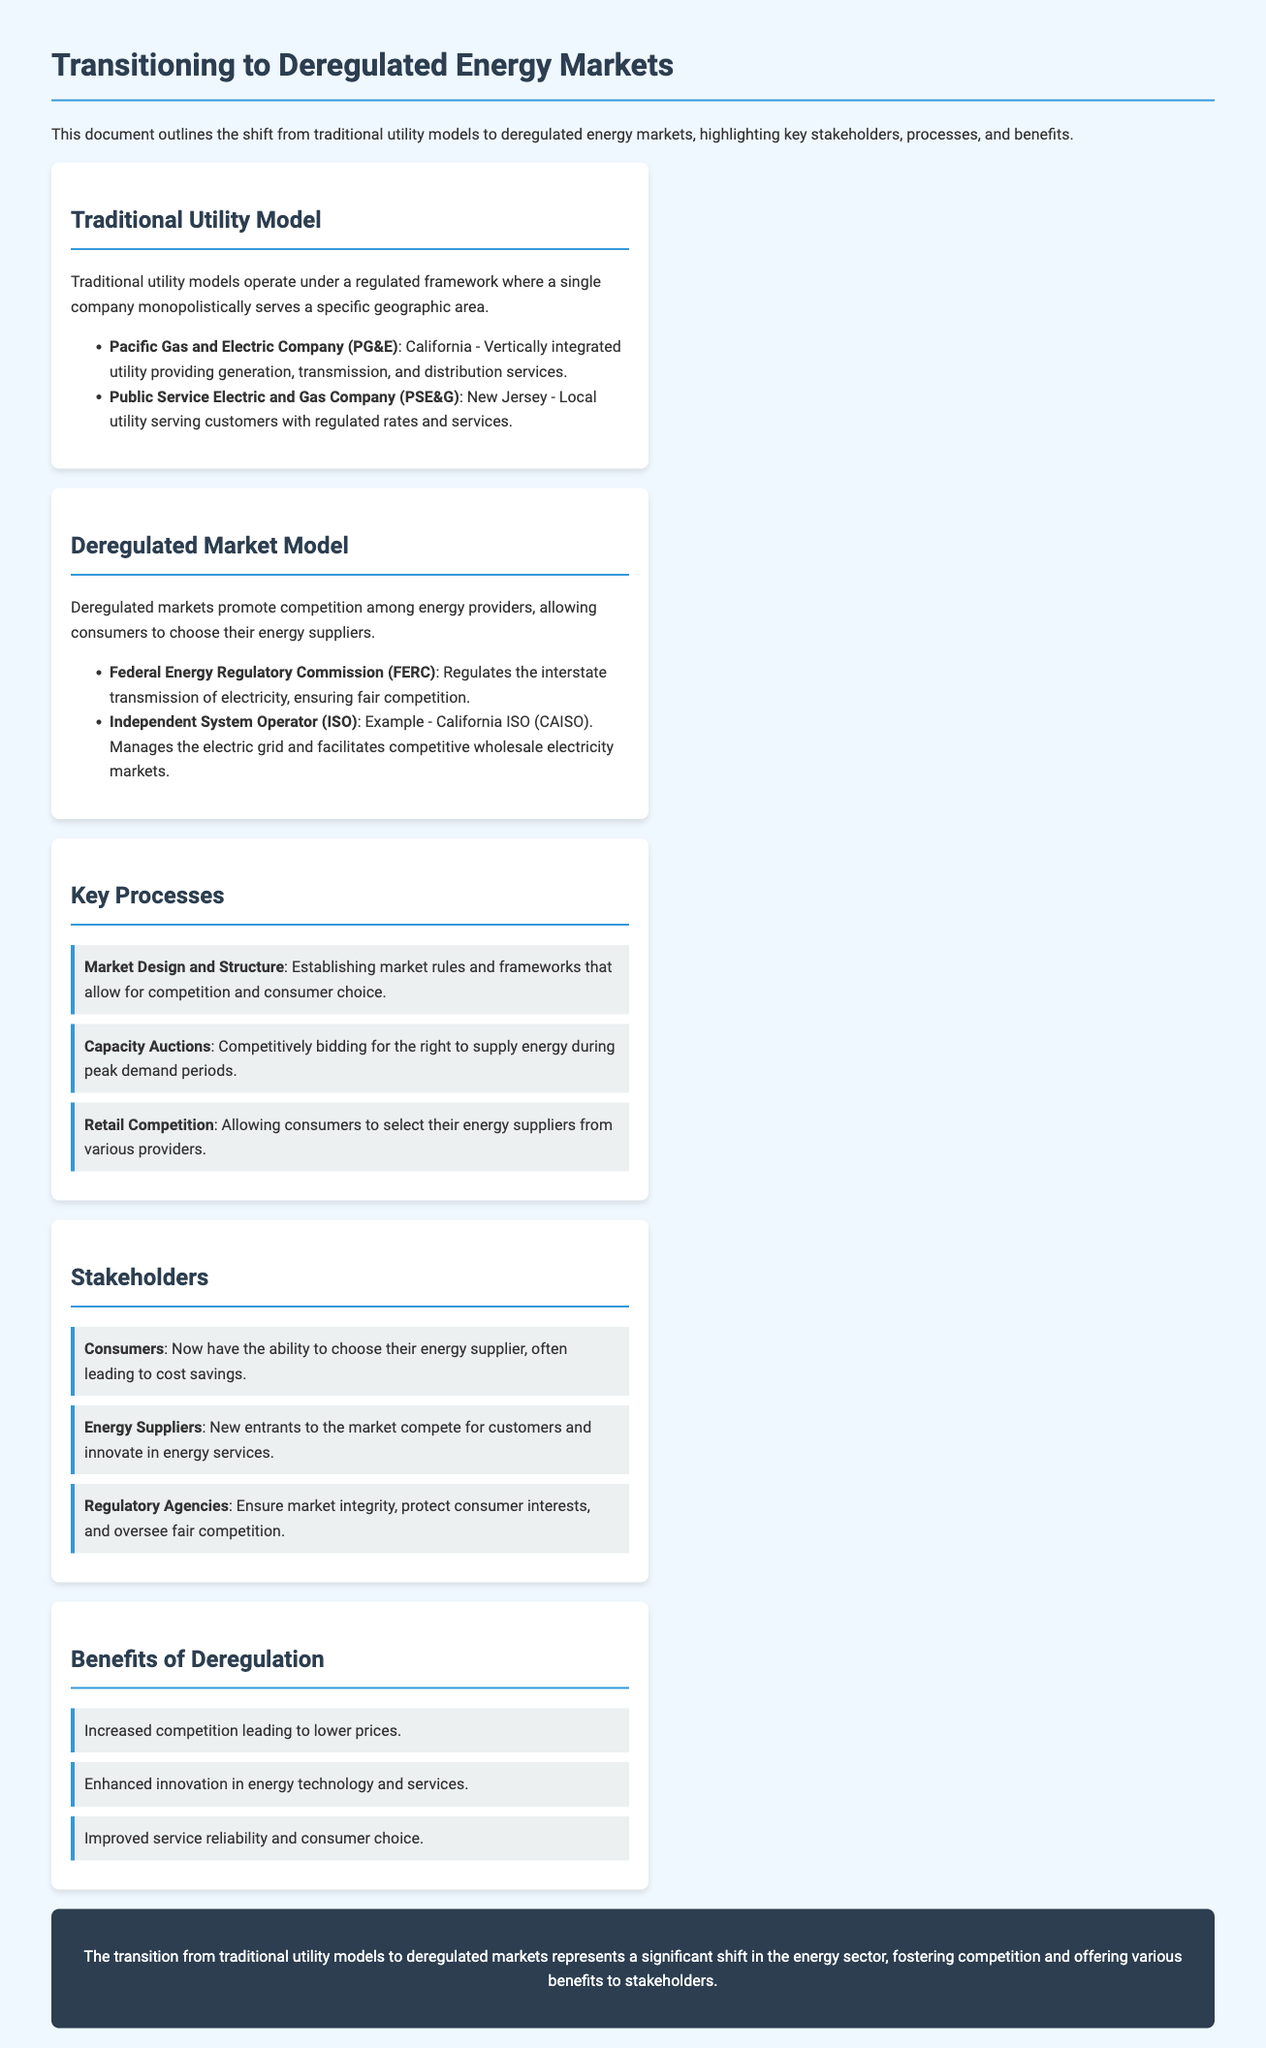What are the names of two traditional utility companies mentioned? The document lists two traditional utility companies as examples of monopolistic service providers in specific areas, which are Pacific Gas and Electric Company (PG&E) and Public Service Electric and Gas Company (PSE&G).
Answer: PG&E, PSE&G What does FERC stand for? The abbreviation FERC is defined within the document as the Federal Energy Regulatory Commission, which regulates the interstate transmission of electricity.
Answer: Federal Energy Regulatory Commission What is one key process involved in deregulated markets? The document enumerates several key processes and one of them is "Capacity Auctions," which involves competitively bidding for energy supply during peak demand periods.
Answer: Capacity Auctions Who benefits from increased competition in deregulated markets? The benefits section outlines that consumers, energy suppliers, and regulatory agencies are key stakeholders who benefit from increased competition, but in this case, consumers are often highlighted as they save costs.
Answer: Consumers What is one benefit of deregulation mentioned? The document lists "Increased competition leading to lower prices" as one of the benefits realized from transitioning to deregulated energy markets.
Answer: Increased competition leading to lower prices 